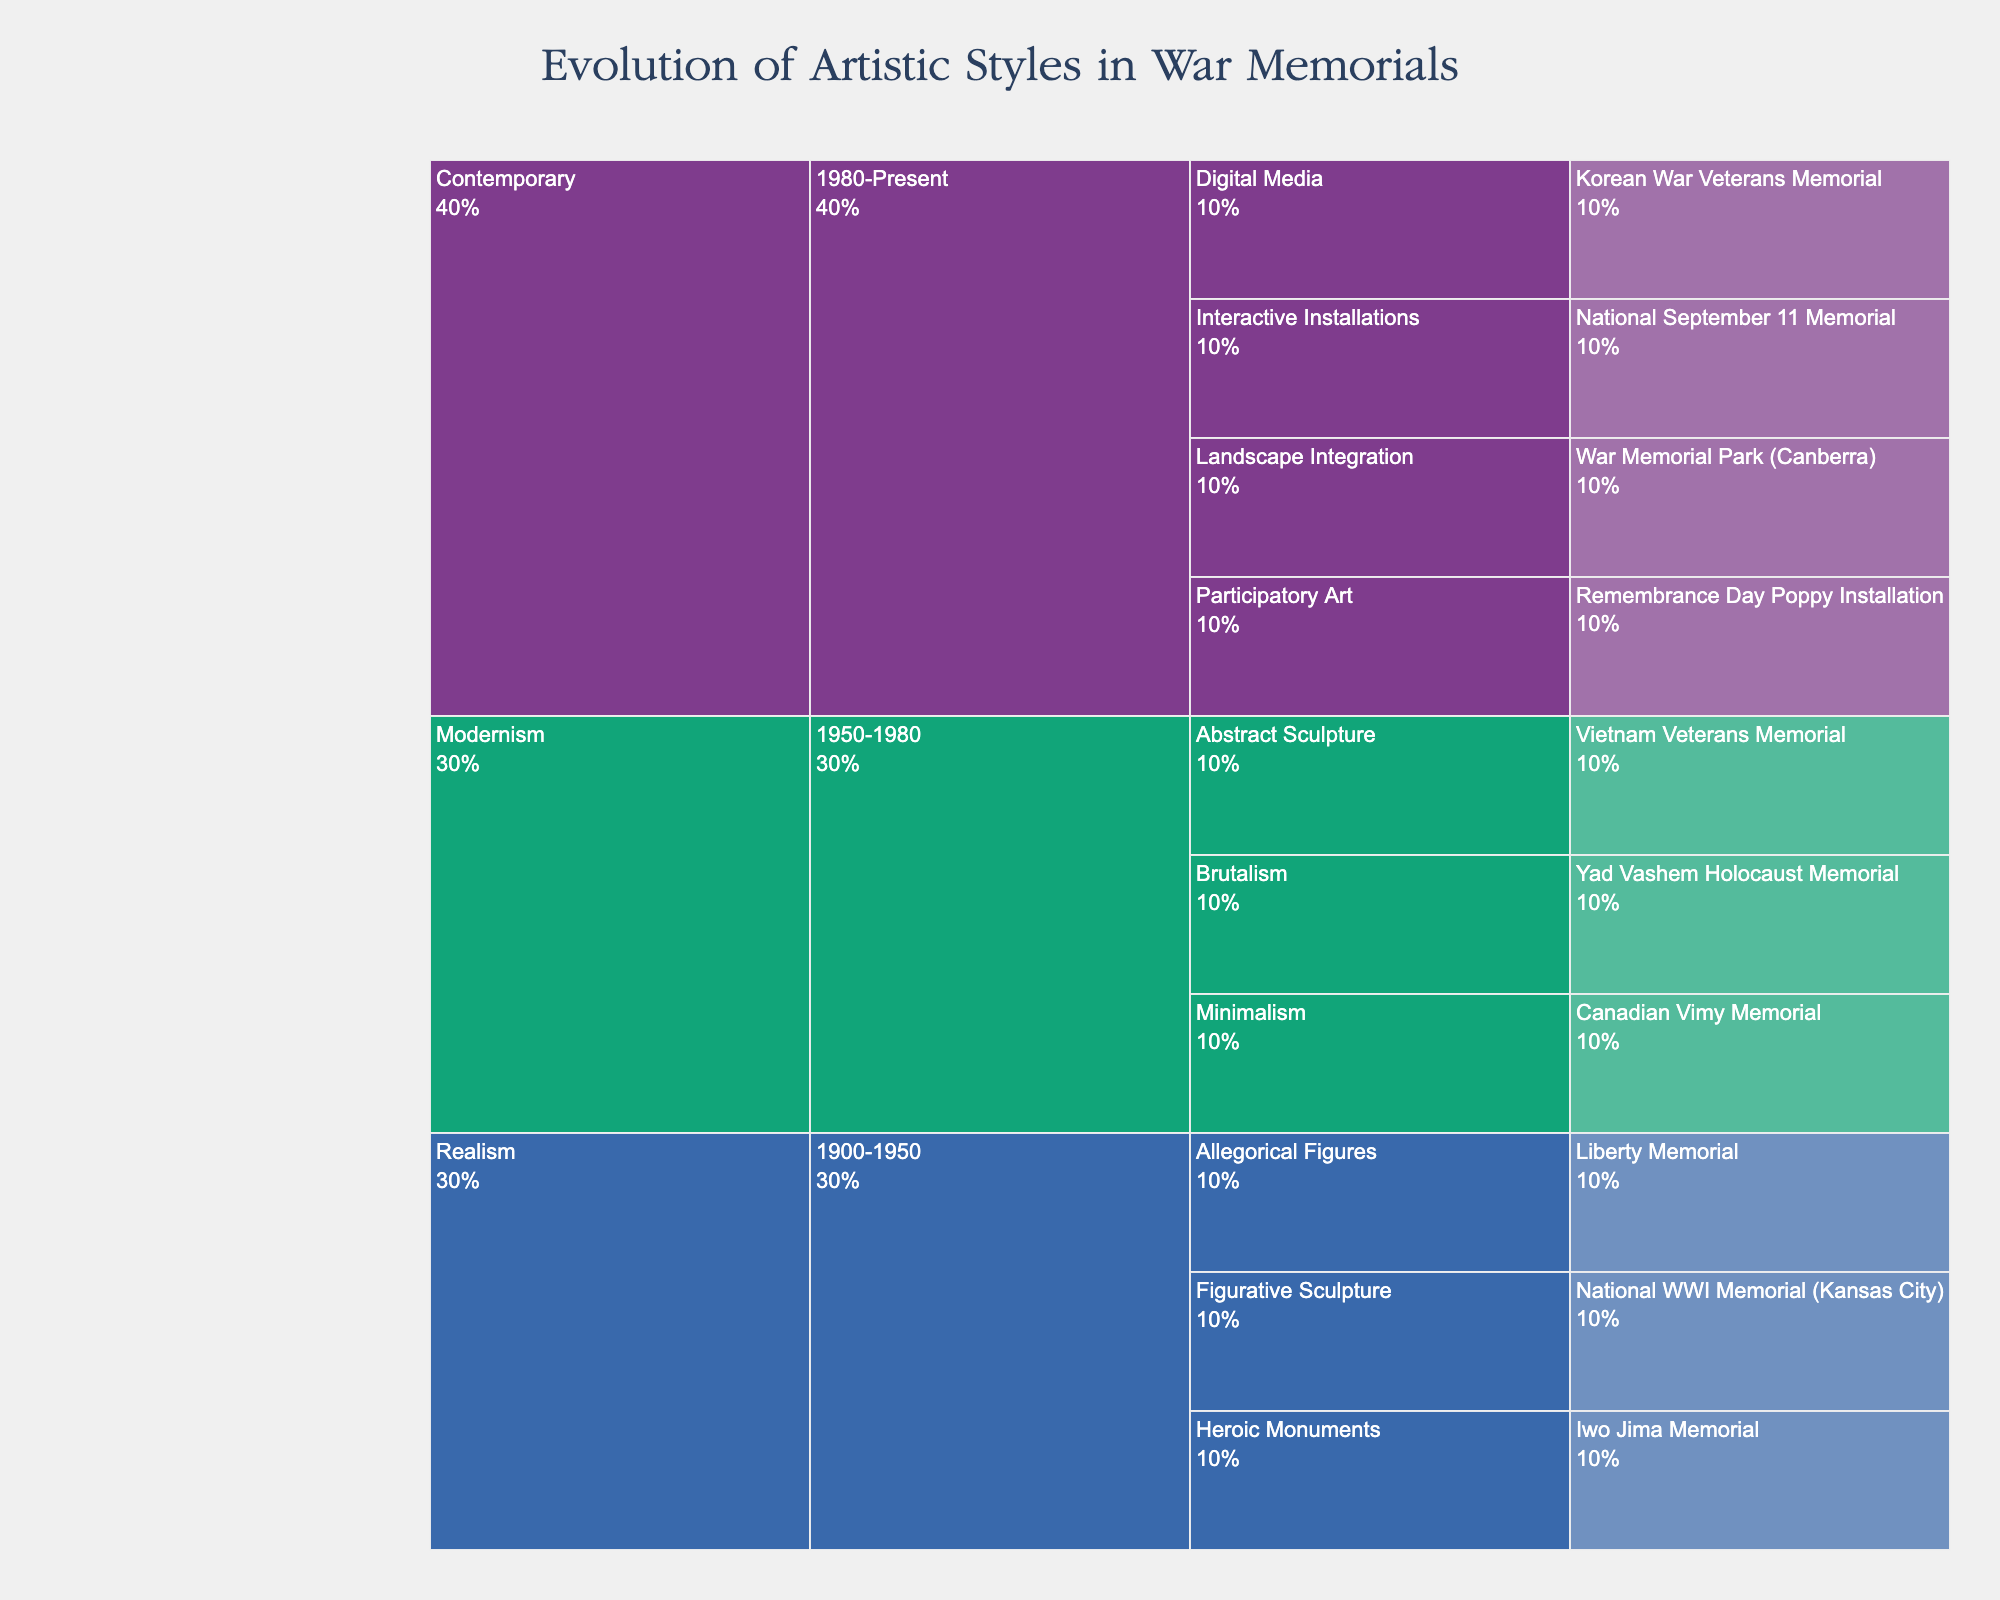What's the title of the Icicle Chart? The title is located at the top of the Icicle Chart.
Answer: Evolution of Artistic Styles in War Memorials What are the three main artistic styles shown in the chart? The main artistic styles are represented by the labels on the topmost layer of the Icicle Chart.
Answer: Realism, Modernism, Contemporary Which specific style was used in the War Memorial Park (Canberra)? Navigate to the Contemporary section, find the era 1980-Present, and look for War Memorial Park (Canberra). The associated specific style is listed.
Answer: Landscape Integration How many notable examples are there under Modernism? Count all the notable examples listed under the Modernism section.
Answer: 3 In which era do we find the Iwo Jima Memorial? Locate the Iwo Jima Memorial within the chart and trace back to its associated era.
Answer: 1900-1950 Which artistic style contains the most specific styles? Compare the number of specific styles listed under each main artistic style by counting them.
Answer: Contemporary Compare the number of notable examples between Realism and Contemporary. Which has more? Count the notable examples under both the Realism and Contemporary sections, then compare the totals.
Answer: Contemporary What percentage of the chart does Modernism represent? Since all primary styles have equal numerical representation, Modernism occupies one-third of the chart.
Answer: Approximately 33% Identify a notable example of Brutalism. Find Brutalism under the Modernism section and identify the notable example listed.
Answer: Yad Vashem Holocaust Memorial Which artistic style features Participatory Art? Locate Participatory Art within the chart and trace back to the main artistic style it falls under.
Answer: Contemporary 